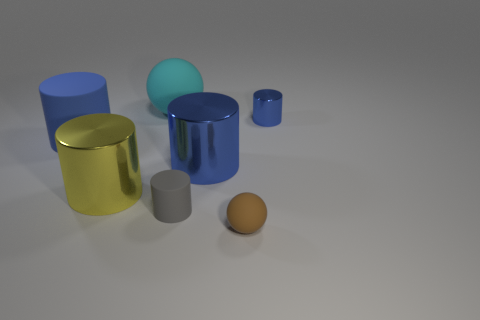Subtract all blue balls. How many blue cylinders are left? 3 Subtract all blue matte cylinders. How many cylinders are left? 4 Subtract all gray cylinders. How many cylinders are left? 4 Subtract all green cylinders. Subtract all gray cubes. How many cylinders are left? 5 Add 1 large red things. How many objects exist? 8 Subtract all balls. How many objects are left? 5 Subtract all tiny metal objects. Subtract all gray matte cylinders. How many objects are left? 5 Add 1 big cylinders. How many big cylinders are left? 4 Add 2 small gray things. How many small gray things exist? 3 Subtract 0 red cylinders. How many objects are left? 7 